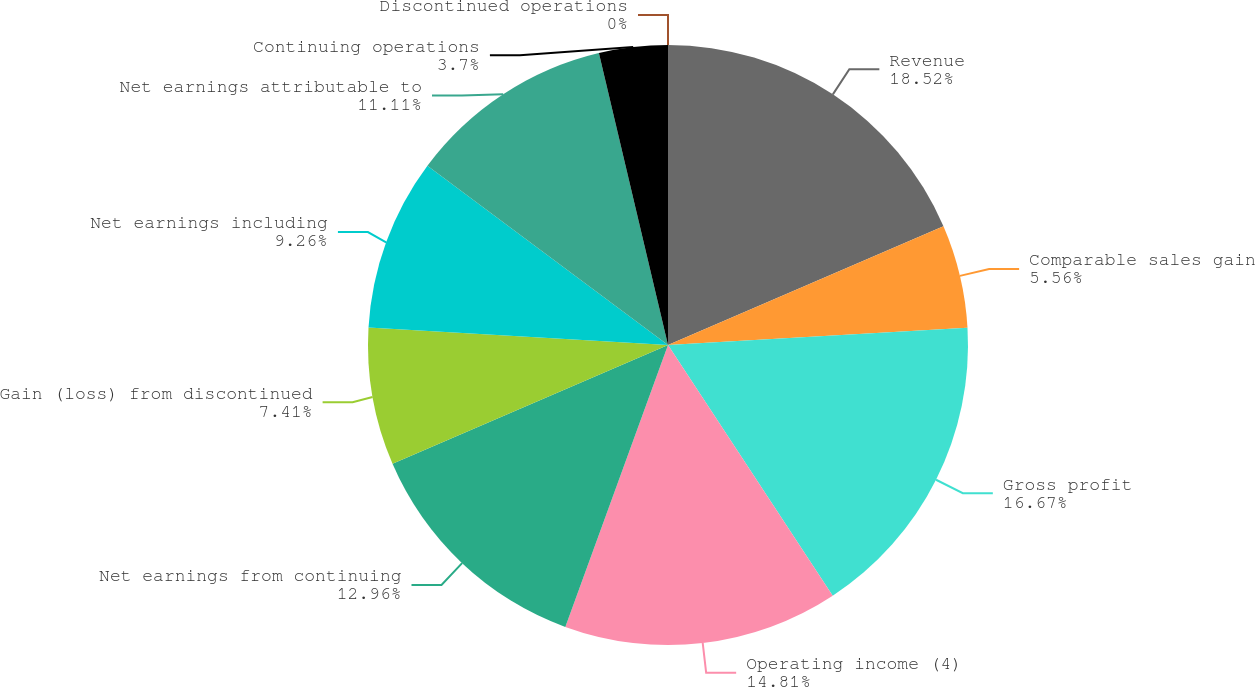Convert chart to OTSL. <chart><loc_0><loc_0><loc_500><loc_500><pie_chart><fcel>Revenue<fcel>Comparable sales gain<fcel>Gross profit<fcel>Operating income (4)<fcel>Net earnings from continuing<fcel>Gain (loss) from discontinued<fcel>Net earnings including<fcel>Net earnings attributable to<fcel>Continuing operations<fcel>Discontinued operations<nl><fcel>18.52%<fcel>5.56%<fcel>16.67%<fcel>14.81%<fcel>12.96%<fcel>7.41%<fcel>9.26%<fcel>11.11%<fcel>3.7%<fcel>0.0%<nl></chart> 